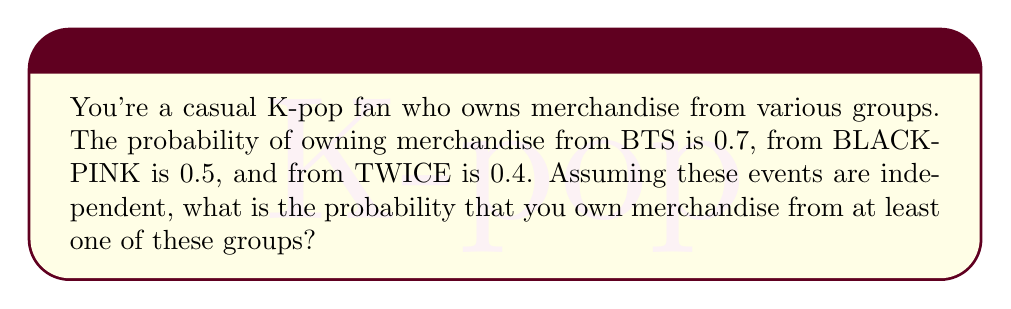Provide a solution to this math problem. To solve this problem, we'll use the complement method:

1) First, let's define our events:
   B: Owning BTS merchandise
   P: Owning BLACKPINK merchandise
   T: Owning TWICE merchandise

2) We want to find P(at least one) = 1 - P(none)

3) The probability of not owning merchandise from each group:
   P(not B) = 1 - 0.7 = 0.3
   P(not P) = 1 - 0.5 = 0.5
   P(not T) = 1 - 0.4 = 0.6

4) Since the events are independent, the probability of not owning merchandise from any of these groups is:
   P(none) = P(not B) × P(not P) × P(not T)
   
   $$ P(\text{none}) = 0.3 \times 0.5 \times 0.6 = 0.09 $$

5) Therefore, the probability of owning merchandise from at least one group is:
   $$ P(\text{at least one}) = 1 - P(\text{none}) = 1 - 0.09 = 0.91 $$
Answer: The probability of owning merchandise from at least one of these K-pop groups is 0.91 or 91%. 